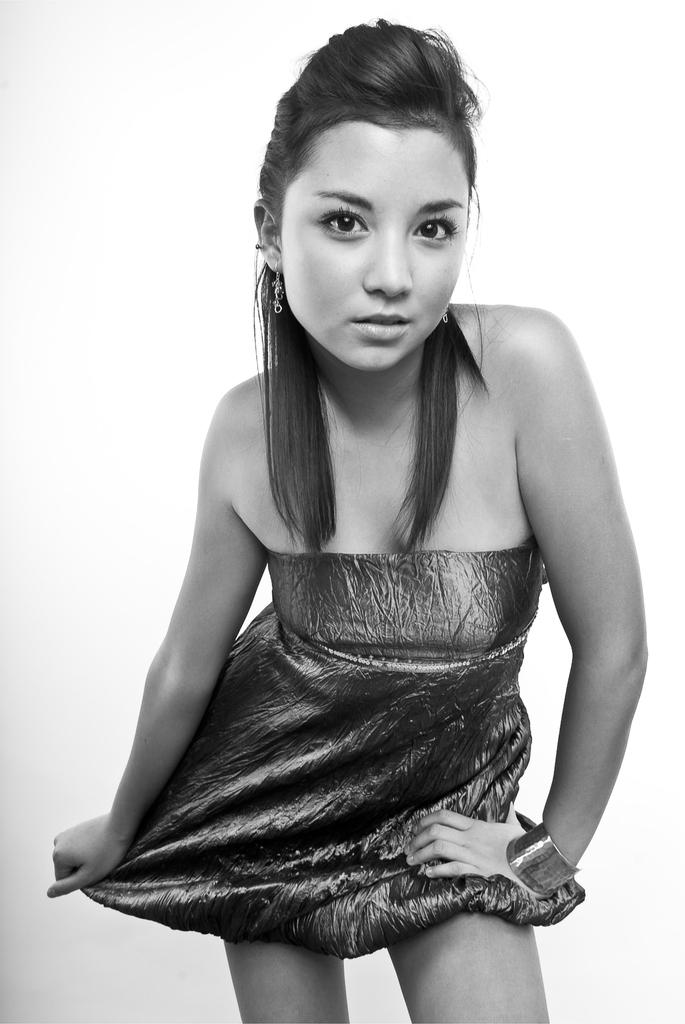What is the color scheme of the image? The image is black and white. Can you describe the main subject of the image? There is a girl in the center of the image. What type of bell can be seen hanging from the girl's neck in the image? There is no bell present in the image; it only features a girl in a black and white setting. 